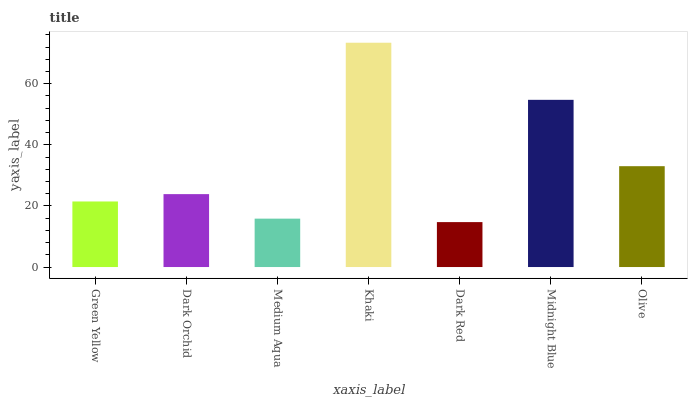Is Dark Red the minimum?
Answer yes or no. Yes. Is Khaki the maximum?
Answer yes or no. Yes. Is Dark Orchid the minimum?
Answer yes or no. No. Is Dark Orchid the maximum?
Answer yes or no. No. Is Dark Orchid greater than Green Yellow?
Answer yes or no. Yes. Is Green Yellow less than Dark Orchid?
Answer yes or no. Yes. Is Green Yellow greater than Dark Orchid?
Answer yes or no. No. Is Dark Orchid less than Green Yellow?
Answer yes or no. No. Is Dark Orchid the high median?
Answer yes or no. Yes. Is Dark Orchid the low median?
Answer yes or no. Yes. Is Midnight Blue the high median?
Answer yes or no. No. Is Midnight Blue the low median?
Answer yes or no. No. 